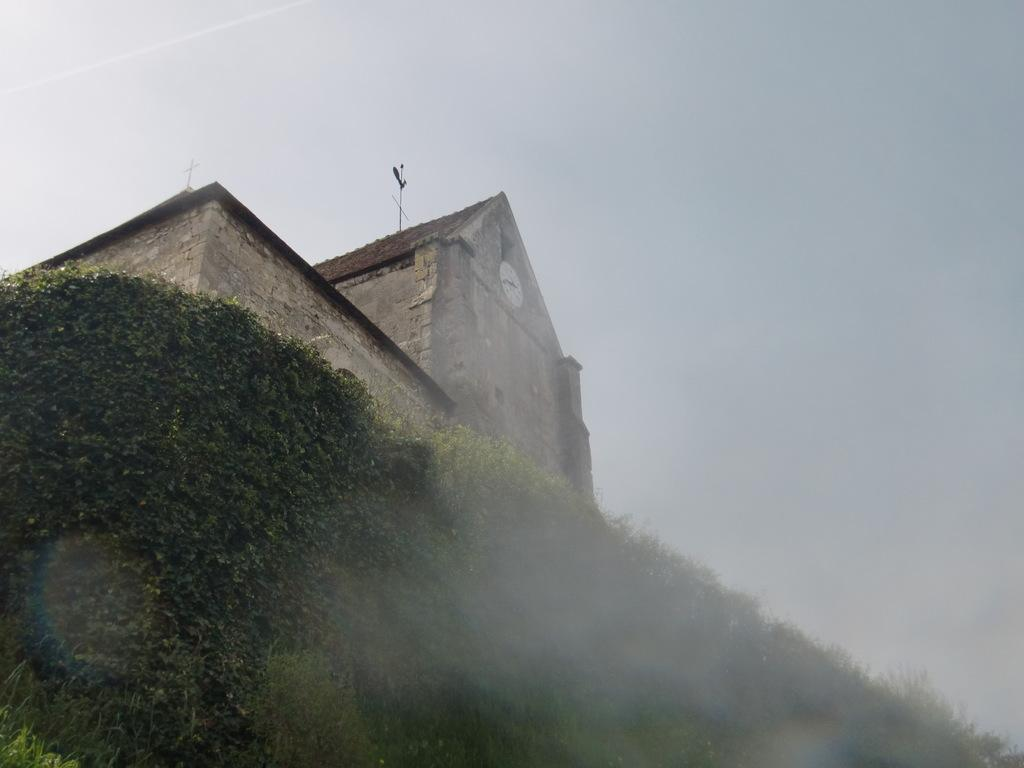What type of structure is visible in the picture? There is a building in the picture. What else can be seen in the picture besides the building? There are plants in the picture. What is the condition of the sky in the picture? The sky is clear in the picture. Can you tell me how many balloons are floating in the sky in the image? There are no balloons present in the image; it only features a building and plants. What type of spark can be seen coming from the building in the image? There is no spark visible in the image; the building and plants are the only subjects present. 